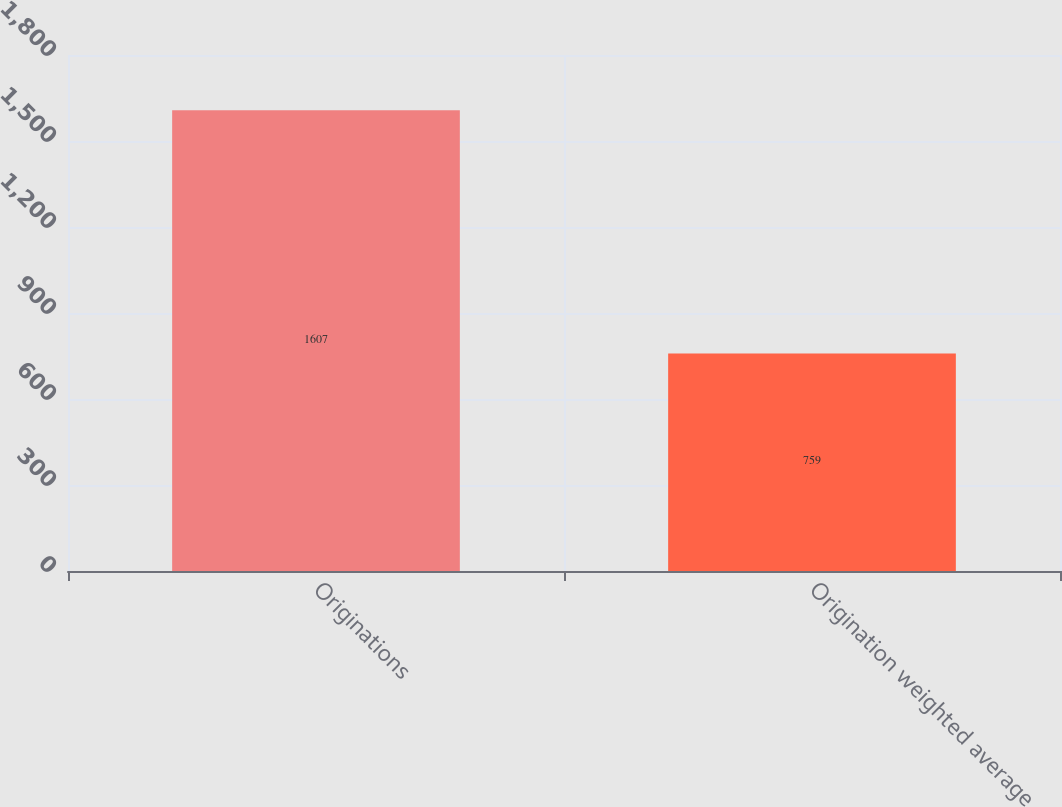Convert chart to OTSL. <chart><loc_0><loc_0><loc_500><loc_500><bar_chart><fcel>Originations<fcel>Origination weighted average<nl><fcel>1607<fcel>759<nl></chart> 